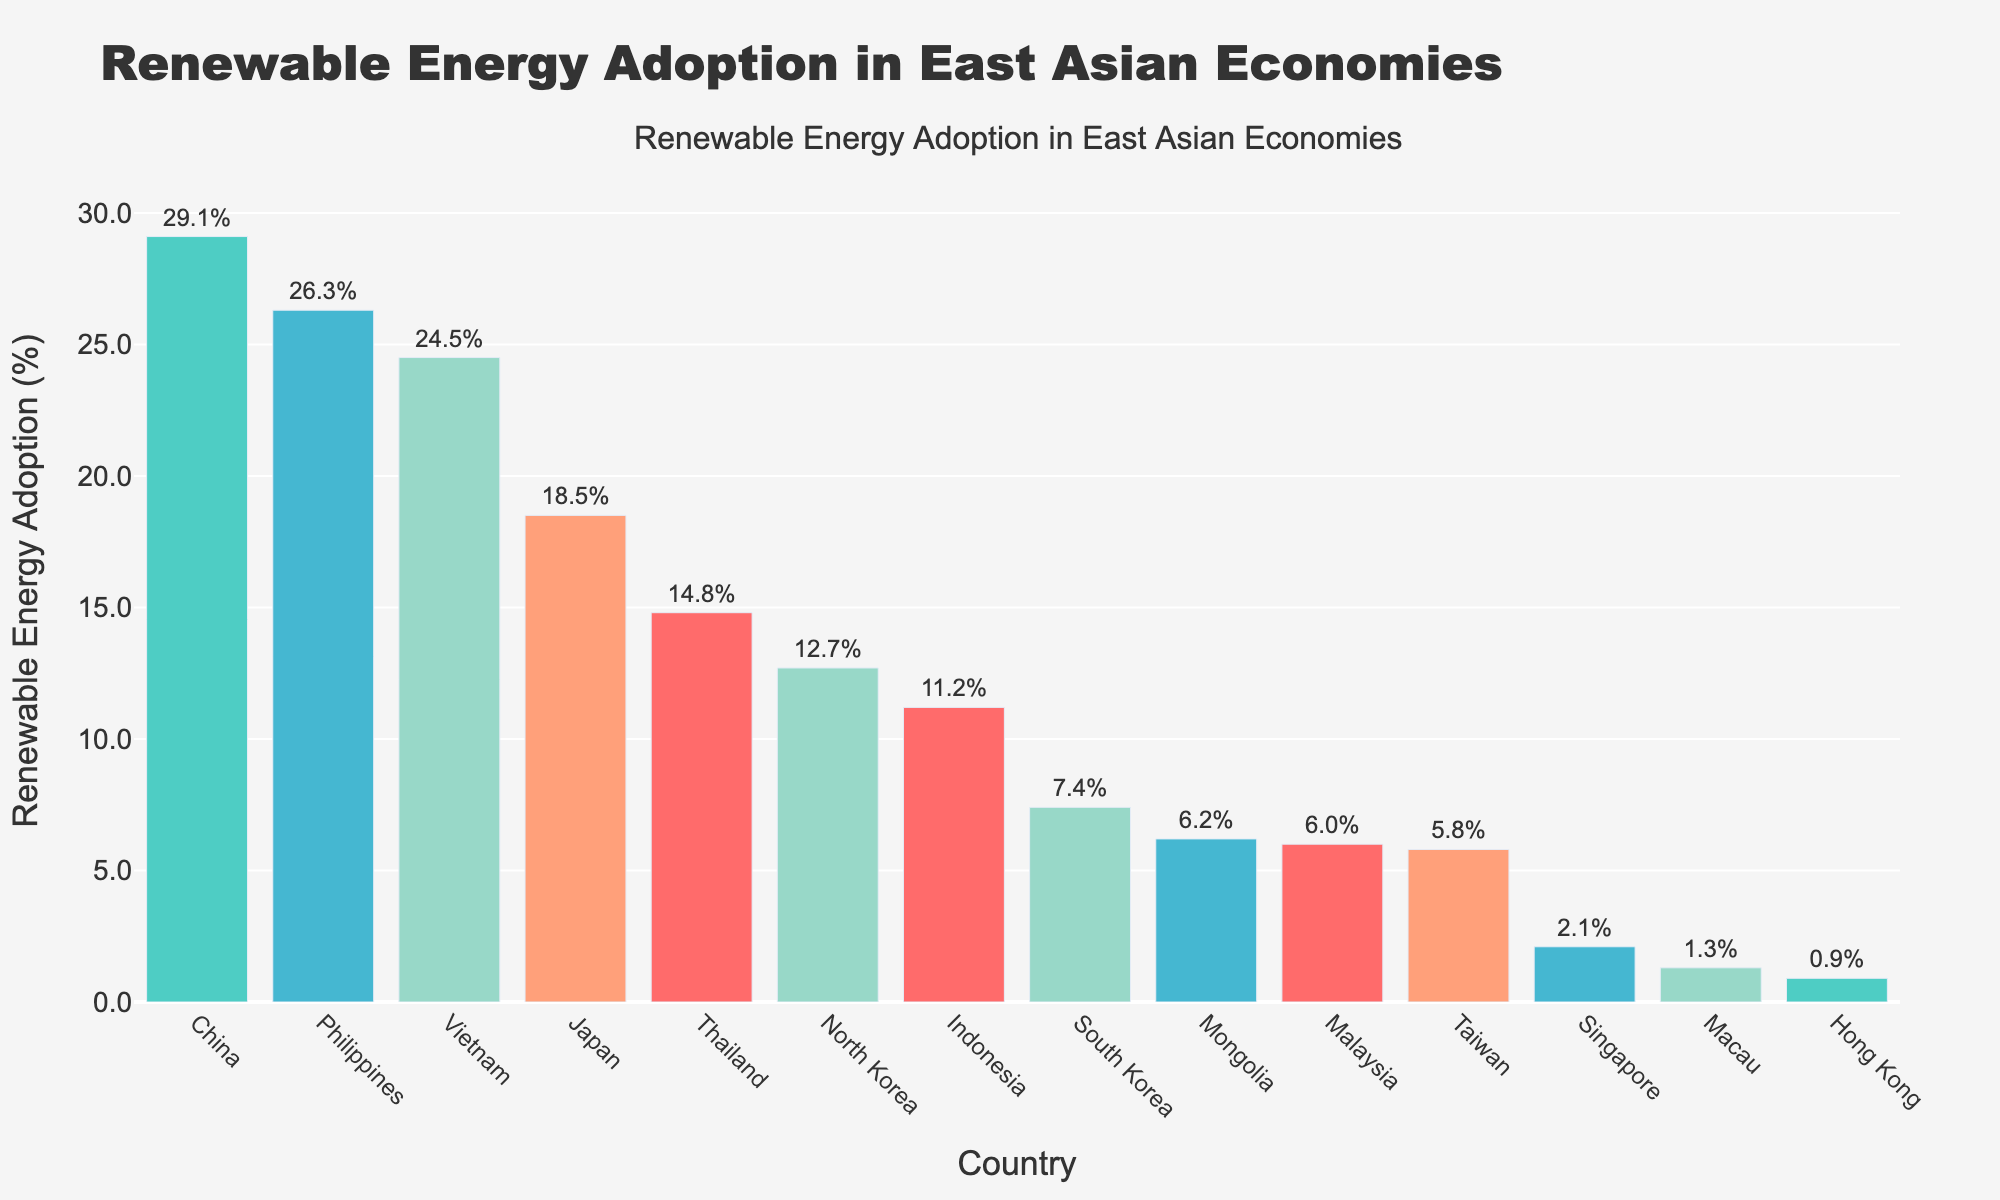Which country has the highest percentage of renewable energy adoption? The bar representing China is the highest among all countries.
Answer: China Which two countries have the lowest percentages of renewable energy adoption, and what are those percentages? Hong Kong has the lowest percentage at 0.9%, followed by Macau with 1.3%.
Answer: Hong Kong: 0.9%, Macau: 1.3% What's the average renewable energy adoption percentage for Japan and South Korea? Japan has a percentage of 18.5% and South Korea has 7.4%. The average is (18.5 + 7.4)/2 = 12.95%.
Answer: 12.95% Compare the renewable energy adoption percentages of the Philippines and Taiwan. Which one is higher and by how much? The Philippines has 26.3% and Taiwan has 5.8%. The difference is 26.3 - 5.8 = 20.5%.
Answer: The Philippines, by 20.5% Which color has been used the most frequently for the bars in the chart? Different colors have been used for the bars, and green appears to be the most frequently used.
Answer: Green Which country has nearly twice the percentage of renewable energy adoption as South Korea? South Korea has 7.4%, and Mongolia has 6.2%, which is nearly twice as much.
Answer: Mongolia Arrange the countries with a renewable energy adoption percentage greater than 20% in descending order. The countries with more than 20% are China (29.1%), Vietnam (24.5%), and the Philippines (26.3%). Ordered: China, Philippines, Vietnam.
Answer: China, Philippines, Vietnam Is Singapore's renewable energy adoption percentage closer to that of Macau or Thailand? Singapore has 2.1%, Macau has 1.3%, and Thailand has 14.8%. The difference between Singapore and Macau is 0.8%, while the difference between Singapore and Thailand is 12.7%. So, it is closer to Macau.
Answer: Macau Calculate the total renewable energy adoption percentage for Hong Kong, Macau, and Singapore combined. Hong Kong has 0.9%, Macau has 1.3%, and Singapore has 2.1%. The total is 0.9 + 1.3 + 2.1 = 4.3%.
Answer: 4.3% Which country has a higher renewable energy adoption percentage, Indonesia or Malaysia? By how much? Indonesia has 11.2% and Malaysia has 6.0%. The difference is 11.2 - 6.0 = 5.2%.
Answer: Indonesia, by 5.2% 